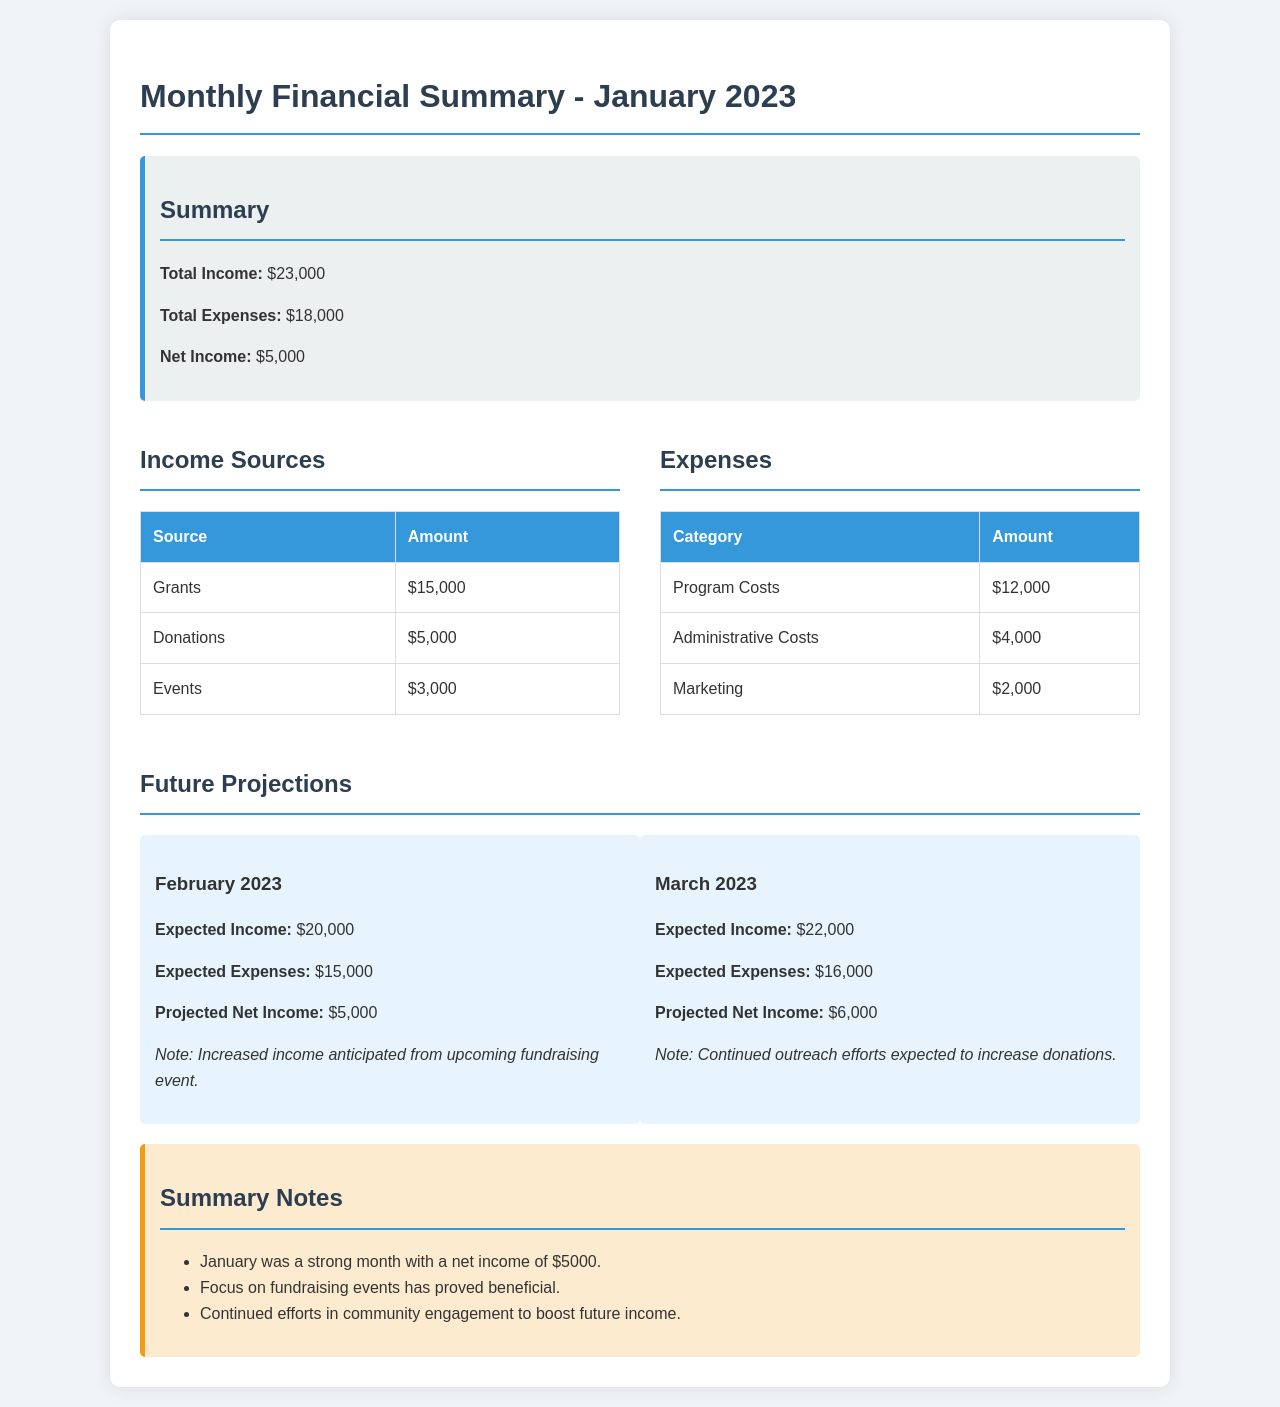what was the total income for January 2023? The total income for January 2023 is explicitly mentioned in the summary section of the document.
Answer: $23,000 what were the total expenses for January 2023? The total expenses for January 2023 are listed in the summary section of the document.
Answer: $18,000 what is the net income for January 2023? The net income is calculated as total income minus total expenses, which is noted in the document.
Answer: $5,000 which source provided the highest income? The income sources table specifies that Grants provided the most income.
Answer: Grants what was the amount spent on Program Costs? The Expenses table details the amount allocated for Program Costs.
Answer: $12,000 what are the expected income and expenses for February 2023? The Future Projections section contains the anticipated income and expenses for February.
Answer: Expected Income: $20,000; Expected Expenses: $15,000 how much is the projected net income for March 2023? The Future Projections section includes the projected net income for March 2023.
Answer: $6,000 what is noted about the fundraising event in February 2023? The note in the Future Projections section indicates an increase in income due to an upcoming fundraising event.
Answer: Increased income anticipated from upcoming fundraising event what are the summary notes for January 2023? The Summary Notes section lists brief observations about January's performance based on the data outlined.
Answer: January was a strong month with a net income of $5000 